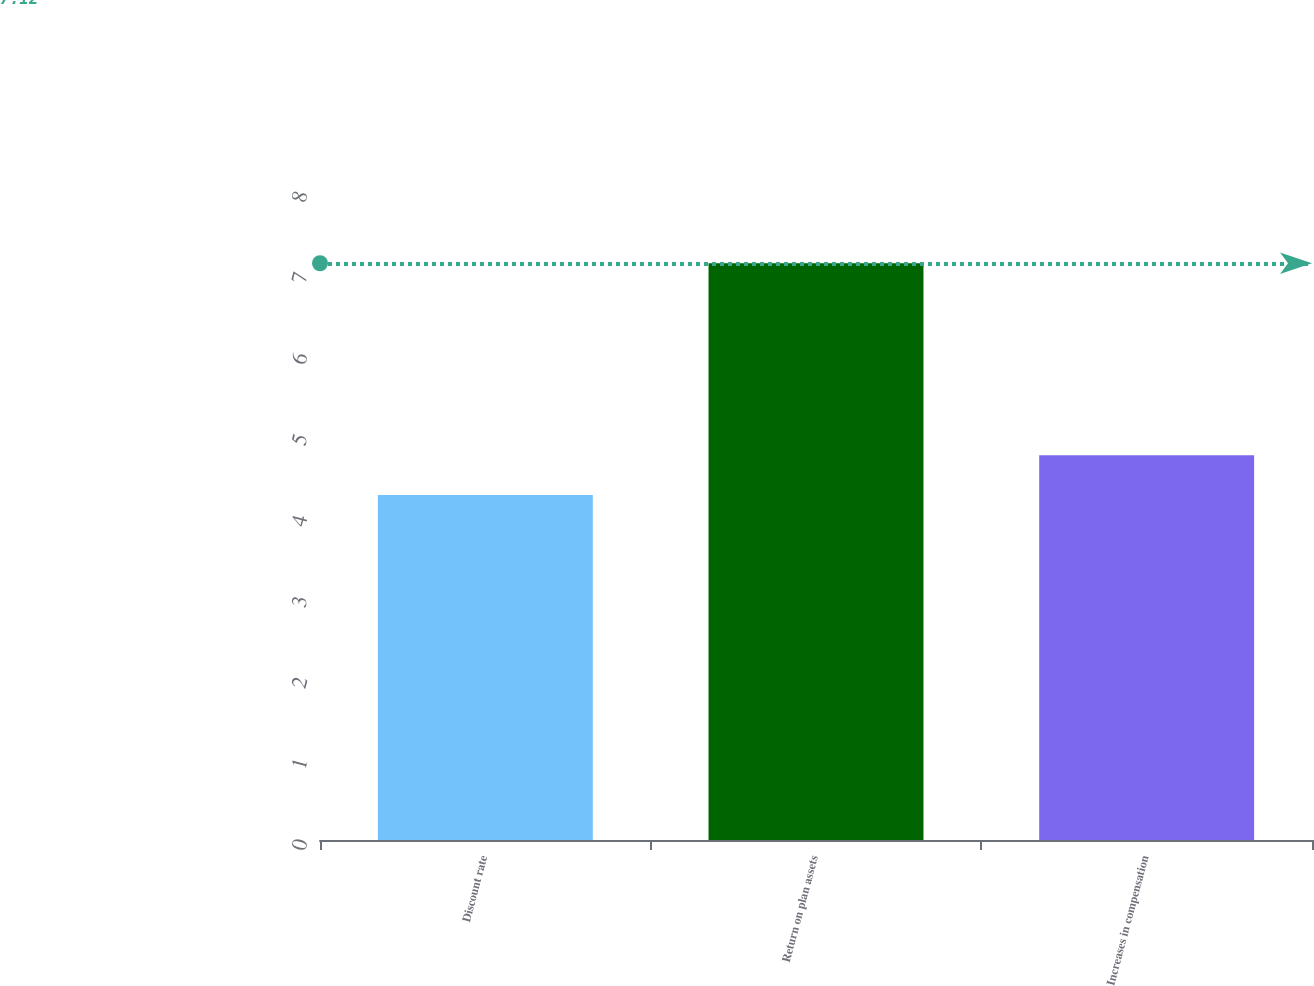<chart> <loc_0><loc_0><loc_500><loc_500><bar_chart><fcel>Discount rate<fcel>Return on plan assets<fcel>Increases in compensation<nl><fcel>4.26<fcel>7.12<fcel>4.75<nl></chart> 